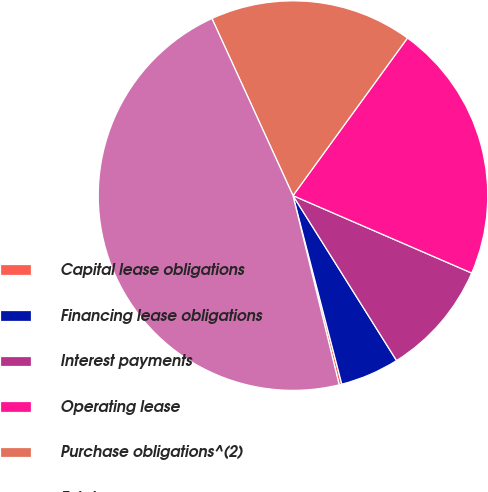Convert chart. <chart><loc_0><loc_0><loc_500><loc_500><pie_chart><fcel>Capital lease obligations<fcel>Financing lease obligations<fcel>Interest payments<fcel>Operating lease<fcel>Purchase obligations^(2)<fcel>Total<nl><fcel>0.22%<fcel>4.89%<fcel>9.57%<fcel>21.51%<fcel>16.83%<fcel>46.98%<nl></chart> 